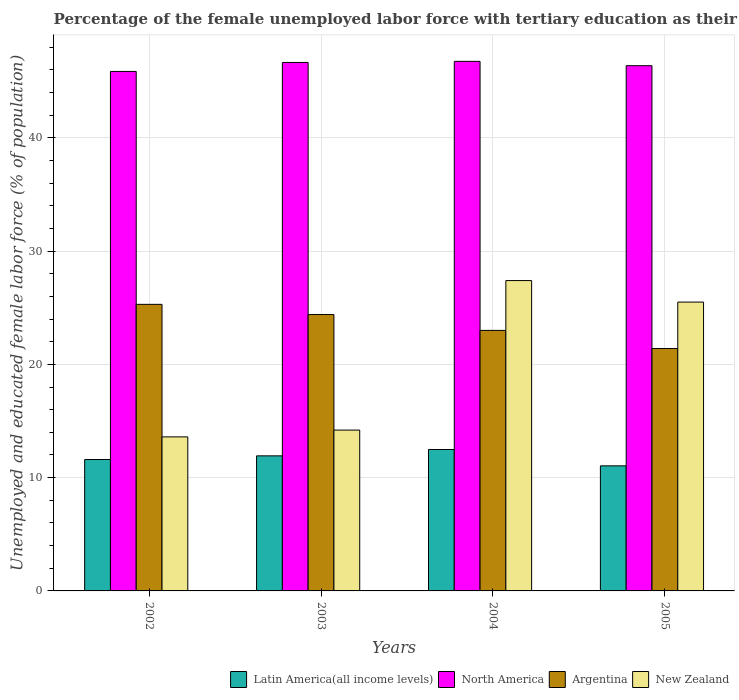How many groups of bars are there?
Ensure brevity in your answer.  4. Are the number of bars on each tick of the X-axis equal?
Your answer should be very brief. Yes. How many bars are there on the 2nd tick from the left?
Keep it short and to the point. 4. How many bars are there on the 2nd tick from the right?
Offer a terse response. 4. What is the label of the 1st group of bars from the left?
Ensure brevity in your answer.  2002. What is the percentage of the unemployed female labor force with tertiary education in Latin America(all income levels) in 2005?
Keep it short and to the point. 11.04. Across all years, what is the maximum percentage of the unemployed female labor force with tertiary education in Latin America(all income levels)?
Your response must be concise. 12.48. Across all years, what is the minimum percentage of the unemployed female labor force with tertiary education in Argentina?
Ensure brevity in your answer.  21.4. What is the total percentage of the unemployed female labor force with tertiary education in Latin America(all income levels) in the graph?
Make the answer very short. 47.05. What is the difference between the percentage of the unemployed female labor force with tertiary education in North America in 2002 and that in 2003?
Provide a short and direct response. -0.79. What is the difference between the percentage of the unemployed female labor force with tertiary education in Argentina in 2005 and the percentage of the unemployed female labor force with tertiary education in New Zealand in 2004?
Your answer should be very brief. -6. What is the average percentage of the unemployed female labor force with tertiary education in North America per year?
Your response must be concise. 46.41. In the year 2003, what is the difference between the percentage of the unemployed female labor force with tertiary education in Argentina and percentage of the unemployed female labor force with tertiary education in New Zealand?
Provide a succinct answer. 10.2. What is the ratio of the percentage of the unemployed female labor force with tertiary education in New Zealand in 2004 to that in 2005?
Ensure brevity in your answer.  1.07. Is the difference between the percentage of the unemployed female labor force with tertiary education in Argentina in 2003 and 2004 greater than the difference between the percentage of the unemployed female labor force with tertiary education in New Zealand in 2003 and 2004?
Offer a terse response. Yes. What is the difference between the highest and the second highest percentage of the unemployed female labor force with tertiary education in New Zealand?
Your answer should be very brief. 1.9. What is the difference between the highest and the lowest percentage of the unemployed female labor force with tertiary education in Argentina?
Give a very brief answer. 3.9. Is the sum of the percentage of the unemployed female labor force with tertiary education in Latin America(all income levels) in 2003 and 2005 greater than the maximum percentage of the unemployed female labor force with tertiary education in North America across all years?
Provide a short and direct response. No. What does the 3rd bar from the left in 2003 represents?
Your response must be concise. Argentina. What does the 2nd bar from the right in 2004 represents?
Your answer should be very brief. Argentina. Is it the case that in every year, the sum of the percentage of the unemployed female labor force with tertiary education in New Zealand and percentage of the unemployed female labor force with tertiary education in Latin America(all income levels) is greater than the percentage of the unemployed female labor force with tertiary education in North America?
Your response must be concise. No. Are all the bars in the graph horizontal?
Provide a short and direct response. No. What is the difference between two consecutive major ticks on the Y-axis?
Your response must be concise. 10. Are the values on the major ticks of Y-axis written in scientific E-notation?
Your response must be concise. No. Where does the legend appear in the graph?
Provide a short and direct response. Bottom right. How many legend labels are there?
Your answer should be very brief. 4. How are the legend labels stacked?
Your response must be concise. Horizontal. What is the title of the graph?
Make the answer very short. Percentage of the female unemployed labor force with tertiary education as their highest grade. What is the label or title of the X-axis?
Your answer should be compact. Years. What is the label or title of the Y-axis?
Your response must be concise. Unemployed and educated female labor force (% of population). What is the Unemployed and educated female labor force (% of population) of Latin America(all income levels) in 2002?
Give a very brief answer. 11.6. What is the Unemployed and educated female labor force (% of population) of North America in 2002?
Your answer should be very brief. 45.86. What is the Unemployed and educated female labor force (% of population) in Argentina in 2002?
Make the answer very short. 25.3. What is the Unemployed and educated female labor force (% of population) in New Zealand in 2002?
Offer a very short reply. 13.6. What is the Unemployed and educated female labor force (% of population) in Latin America(all income levels) in 2003?
Make the answer very short. 11.92. What is the Unemployed and educated female labor force (% of population) in North America in 2003?
Provide a short and direct response. 46.66. What is the Unemployed and educated female labor force (% of population) in Argentina in 2003?
Your answer should be very brief. 24.4. What is the Unemployed and educated female labor force (% of population) of New Zealand in 2003?
Offer a terse response. 14.2. What is the Unemployed and educated female labor force (% of population) in Latin America(all income levels) in 2004?
Make the answer very short. 12.48. What is the Unemployed and educated female labor force (% of population) in North America in 2004?
Provide a succinct answer. 46.75. What is the Unemployed and educated female labor force (% of population) in Argentina in 2004?
Give a very brief answer. 23. What is the Unemployed and educated female labor force (% of population) of New Zealand in 2004?
Offer a terse response. 27.4. What is the Unemployed and educated female labor force (% of population) of Latin America(all income levels) in 2005?
Make the answer very short. 11.04. What is the Unemployed and educated female labor force (% of population) of North America in 2005?
Offer a very short reply. 46.37. What is the Unemployed and educated female labor force (% of population) of Argentina in 2005?
Offer a very short reply. 21.4. Across all years, what is the maximum Unemployed and educated female labor force (% of population) in Latin America(all income levels)?
Your answer should be compact. 12.48. Across all years, what is the maximum Unemployed and educated female labor force (% of population) of North America?
Provide a short and direct response. 46.75. Across all years, what is the maximum Unemployed and educated female labor force (% of population) in Argentina?
Provide a short and direct response. 25.3. Across all years, what is the maximum Unemployed and educated female labor force (% of population) in New Zealand?
Offer a very short reply. 27.4. Across all years, what is the minimum Unemployed and educated female labor force (% of population) in Latin America(all income levels)?
Your answer should be very brief. 11.04. Across all years, what is the minimum Unemployed and educated female labor force (% of population) in North America?
Your answer should be very brief. 45.86. Across all years, what is the minimum Unemployed and educated female labor force (% of population) of Argentina?
Provide a short and direct response. 21.4. Across all years, what is the minimum Unemployed and educated female labor force (% of population) of New Zealand?
Your answer should be very brief. 13.6. What is the total Unemployed and educated female labor force (% of population) of Latin America(all income levels) in the graph?
Provide a succinct answer. 47.05. What is the total Unemployed and educated female labor force (% of population) of North America in the graph?
Offer a terse response. 185.64. What is the total Unemployed and educated female labor force (% of population) of Argentina in the graph?
Provide a succinct answer. 94.1. What is the total Unemployed and educated female labor force (% of population) of New Zealand in the graph?
Provide a short and direct response. 80.7. What is the difference between the Unemployed and educated female labor force (% of population) of Latin America(all income levels) in 2002 and that in 2003?
Provide a short and direct response. -0.32. What is the difference between the Unemployed and educated female labor force (% of population) of North America in 2002 and that in 2003?
Offer a very short reply. -0.79. What is the difference between the Unemployed and educated female labor force (% of population) in Latin America(all income levels) in 2002 and that in 2004?
Your response must be concise. -0.88. What is the difference between the Unemployed and educated female labor force (% of population) in North America in 2002 and that in 2004?
Provide a short and direct response. -0.89. What is the difference between the Unemployed and educated female labor force (% of population) of New Zealand in 2002 and that in 2004?
Provide a short and direct response. -13.8. What is the difference between the Unemployed and educated female labor force (% of population) in Latin America(all income levels) in 2002 and that in 2005?
Provide a short and direct response. 0.56. What is the difference between the Unemployed and educated female labor force (% of population) in North America in 2002 and that in 2005?
Provide a short and direct response. -0.51. What is the difference between the Unemployed and educated female labor force (% of population) of Latin America(all income levels) in 2003 and that in 2004?
Keep it short and to the point. -0.56. What is the difference between the Unemployed and educated female labor force (% of population) in North America in 2003 and that in 2004?
Your answer should be compact. -0.1. What is the difference between the Unemployed and educated female labor force (% of population) in Latin America(all income levels) in 2003 and that in 2005?
Offer a terse response. 0.88. What is the difference between the Unemployed and educated female labor force (% of population) in North America in 2003 and that in 2005?
Provide a short and direct response. 0.29. What is the difference between the Unemployed and educated female labor force (% of population) in Argentina in 2003 and that in 2005?
Keep it short and to the point. 3. What is the difference between the Unemployed and educated female labor force (% of population) in New Zealand in 2003 and that in 2005?
Keep it short and to the point. -11.3. What is the difference between the Unemployed and educated female labor force (% of population) in Latin America(all income levels) in 2004 and that in 2005?
Make the answer very short. 1.44. What is the difference between the Unemployed and educated female labor force (% of population) in North America in 2004 and that in 2005?
Provide a short and direct response. 0.38. What is the difference between the Unemployed and educated female labor force (% of population) in New Zealand in 2004 and that in 2005?
Give a very brief answer. 1.9. What is the difference between the Unemployed and educated female labor force (% of population) of Latin America(all income levels) in 2002 and the Unemployed and educated female labor force (% of population) of North America in 2003?
Your response must be concise. -35.05. What is the difference between the Unemployed and educated female labor force (% of population) in Latin America(all income levels) in 2002 and the Unemployed and educated female labor force (% of population) in Argentina in 2003?
Your answer should be very brief. -12.8. What is the difference between the Unemployed and educated female labor force (% of population) of Latin America(all income levels) in 2002 and the Unemployed and educated female labor force (% of population) of New Zealand in 2003?
Give a very brief answer. -2.6. What is the difference between the Unemployed and educated female labor force (% of population) of North America in 2002 and the Unemployed and educated female labor force (% of population) of Argentina in 2003?
Your response must be concise. 21.46. What is the difference between the Unemployed and educated female labor force (% of population) in North America in 2002 and the Unemployed and educated female labor force (% of population) in New Zealand in 2003?
Your answer should be compact. 31.66. What is the difference between the Unemployed and educated female labor force (% of population) of Latin America(all income levels) in 2002 and the Unemployed and educated female labor force (% of population) of North America in 2004?
Ensure brevity in your answer.  -35.15. What is the difference between the Unemployed and educated female labor force (% of population) of Latin America(all income levels) in 2002 and the Unemployed and educated female labor force (% of population) of Argentina in 2004?
Make the answer very short. -11.4. What is the difference between the Unemployed and educated female labor force (% of population) of Latin America(all income levels) in 2002 and the Unemployed and educated female labor force (% of population) of New Zealand in 2004?
Give a very brief answer. -15.8. What is the difference between the Unemployed and educated female labor force (% of population) of North America in 2002 and the Unemployed and educated female labor force (% of population) of Argentina in 2004?
Offer a terse response. 22.86. What is the difference between the Unemployed and educated female labor force (% of population) in North America in 2002 and the Unemployed and educated female labor force (% of population) in New Zealand in 2004?
Your answer should be compact. 18.46. What is the difference between the Unemployed and educated female labor force (% of population) of Latin America(all income levels) in 2002 and the Unemployed and educated female labor force (% of population) of North America in 2005?
Offer a very short reply. -34.77. What is the difference between the Unemployed and educated female labor force (% of population) of Latin America(all income levels) in 2002 and the Unemployed and educated female labor force (% of population) of Argentina in 2005?
Offer a terse response. -9.8. What is the difference between the Unemployed and educated female labor force (% of population) of Latin America(all income levels) in 2002 and the Unemployed and educated female labor force (% of population) of New Zealand in 2005?
Provide a short and direct response. -13.9. What is the difference between the Unemployed and educated female labor force (% of population) of North America in 2002 and the Unemployed and educated female labor force (% of population) of Argentina in 2005?
Your answer should be compact. 24.46. What is the difference between the Unemployed and educated female labor force (% of population) of North America in 2002 and the Unemployed and educated female labor force (% of population) of New Zealand in 2005?
Offer a terse response. 20.36. What is the difference between the Unemployed and educated female labor force (% of population) in Argentina in 2002 and the Unemployed and educated female labor force (% of population) in New Zealand in 2005?
Provide a succinct answer. -0.2. What is the difference between the Unemployed and educated female labor force (% of population) in Latin America(all income levels) in 2003 and the Unemployed and educated female labor force (% of population) in North America in 2004?
Offer a very short reply. -34.83. What is the difference between the Unemployed and educated female labor force (% of population) of Latin America(all income levels) in 2003 and the Unemployed and educated female labor force (% of population) of Argentina in 2004?
Offer a very short reply. -11.08. What is the difference between the Unemployed and educated female labor force (% of population) in Latin America(all income levels) in 2003 and the Unemployed and educated female labor force (% of population) in New Zealand in 2004?
Ensure brevity in your answer.  -15.48. What is the difference between the Unemployed and educated female labor force (% of population) of North America in 2003 and the Unemployed and educated female labor force (% of population) of Argentina in 2004?
Your answer should be very brief. 23.66. What is the difference between the Unemployed and educated female labor force (% of population) in North America in 2003 and the Unemployed and educated female labor force (% of population) in New Zealand in 2004?
Provide a succinct answer. 19.26. What is the difference between the Unemployed and educated female labor force (% of population) of Argentina in 2003 and the Unemployed and educated female labor force (% of population) of New Zealand in 2004?
Provide a succinct answer. -3. What is the difference between the Unemployed and educated female labor force (% of population) in Latin America(all income levels) in 2003 and the Unemployed and educated female labor force (% of population) in North America in 2005?
Your answer should be very brief. -34.44. What is the difference between the Unemployed and educated female labor force (% of population) of Latin America(all income levels) in 2003 and the Unemployed and educated female labor force (% of population) of Argentina in 2005?
Make the answer very short. -9.48. What is the difference between the Unemployed and educated female labor force (% of population) in Latin America(all income levels) in 2003 and the Unemployed and educated female labor force (% of population) in New Zealand in 2005?
Your answer should be very brief. -13.58. What is the difference between the Unemployed and educated female labor force (% of population) in North America in 2003 and the Unemployed and educated female labor force (% of population) in Argentina in 2005?
Provide a succinct answer. 25.26. What is the difference between the Unemployed and educated female labor force (% of population) in North America in 2003 and the Unemployed and educated female labor force (% of population) in New Zealand in 2005?
Make the answer very short. 21.16. What is the difference between the Unemployed and educated female labor force (% of population) in Latin America(all income levels) in 2004 and the Unemployed and educated female labor force (% of population) in North America in 2005?
Your answer should be compact. -33.88. What is the difference between the Unemployed and educated female labor force (% of population) of Latin America(all income levels) in 2004 and the Unemployed and educated female labor force (% of population) of Argentina in 2005?
Your response must be concise. -8.92. What is the difference between the Unemployed and educated female labor force (% of population) of Latin America(all income levels) in 2004 and the Unemployed and educated female labor force (% of population) of New Zealand in 2005?
Give a very brief answer. -13.02. What is the difference between the Unemployed and educated female labor force (% of population) in North America in 2004 and the Unemployed and educated female labor force (% of population) in Argentina in 2005?
Provide a short and direct response. 25.35. What is the difference between the Unemployed and educated female labor force (% of population) of North America in 2004 and the Unemployed and educated female labor force (% of population) of New Zealand in 2005?
Your answer should be very brief. 21.25. What is the average Unemployed and educated female labor force (% of population) of Latin America(all income levels) per year?
Your response must be concise. 11.76. What is the average Unemployed and educated female labor force (% of population) in North America per year?
Keep it short and to the point. 46.41. What is the average Unemployed and educated female labor force (% of population) in Argentina per year?
Provide a short and direct response. 23.52. What is the average Unemployed and educated female labor force (% of population) of New Zealand per year?
Offer a terse response. 20.18. In the year 2002, what is the difference between the Unemployed and educated female labor force (% of population) of Latin America(all income levels) and Unemployed and educated female labor force (% of population) of North America?
Offer a terse response. -34.26. In the year 2002, what is the difference between the Unemployed and educated female labor force (% of population) in Latin America(all income levels) and Unemployed and educated female labor force (% of population) in Argentina?
Offer a terse response. -13.7. In the year 2002, what is the difference between the Unemployed and educated female labor force (% of population) in Latin America(all income levels) and Unemployed and educated female labor force (% of population) in New Zealand?
Give a very brief answer. -2. In the year 2002, what is the difference between the Unemployed and educated female labor force (% of population) of North America and Unemployed and educated female labor force (% of population) of Argentina?
Your answer should be very brief. 20.56. In the year 2002, what is the difference between the Unemployed and educated female labor force (% of population) in North America and Unemployed and educated female labor force (% of population) in New Zealand?
Your response must be concise. 32.26. In the year 2002, what is the difference between the Unemployed and educated female labor force (% of population) of Argentina and Unemployed and educated female labor force (% of population) of New Zealand?
Your response must be concise. 11.7. In the year 2003, what is the difference between the Unemployed and educated female labor force (% of population) in Latin America(all income levels) and Unemployed and educated female labor force (% of population) in North America?
Offer a very short reply. -34.73. In the year 2003, what is the difference between the Unemployed and educated female labor force (% of population) in Latin America(all income levels) and Unemployed and educated female labor force (% of population) in Argentina?
Offer a very short reply. -12.48. In the year 2003, what is the difference between the Unemployed and educated female labor force (% of population) in Latin America(all income levels) and Unemployed and educated female labor force (% of population) in New Zealand?
Provide a short and direct response. -2.28. In the year 2003, what is the difference between the Unemployed and educated female labor force (% of population) of North America and Unemployed and educated female labor force (% of population) of Argentina?
Offer a very short reply. 22.26. In the year 2003, what is the difference between the Unemployed and educated female labor force (% of population) of North America and Unemployed and educated female labor force (% of population) of New Zealand?
Offer a terse response. 32.46. In the year 2003, what is the difference between the Unemployed and educated female labor force (% of population) of Argentina and Unemployed and educated female labor force (% of population) of New Zealand?
Make the answer very short. 10.2. In the year 2004, what is the difference between the Unemployed and educated female labor force (% of population) of Latin America(all income levels) and Unemployed and educated female labor force (% of population) of North America?
Give a very brief answer. -34.27. In the year 2004, what is the difference between the Unemployed and educated female labor force (% of population) in Latin America(all income levels) and Unemployed and educated female labor force (% of population) in Argentina?
Your answer should be compact. -10.52. In the year 2004, what is the difference between the Unemployed and educated female labor force (% of population) in Latin America(all income levels) and Unemployed and educated female labor force (% of population) in New Zealand?
Provide a short and direct response. -14.92. In the year 2004, what is the difference between the Unemployed and educated female labor force (% of population) of North America and Unemployed and educated female labor force (% of population) of Argentina?
Provide a succinct answer. 23.75. In the year 2004, what is the difference between the Unemployed and educated female labor force (% of population) of North America and Unemployed and educated female labor force (% of population) of New Zealand?
Keep it short and to the point. 19.35. In the year 2005, what is the difference between the Unemployed and educated female labor force (% of population) in Latin America(all income levels) and Unemployed and educated female labor force (% of population) in North America?
Make the answer very short. -35.33. In the year 2005, what is the difference between the Unemployed and educated female labor force (% of population) in Latin America(all income levels) and Unemployed and educated female labor force (% of population) in Argentina?
Offer a terse response. -10.36. In the year 2005, what is the difference between the Unemployed and educated female labor force (% of population) of Latin America(all income levels) and Unemployed and educated female labor force (% of population) of New Zealand?
Make the answer very short. -14.46. In the year 2005, what is the difference between the Unemployed and educated female labor force (% of population) of North America and Unemployed and educated female labor force (% of population) of Argentina?
Offer a terse response. 24.97. In the year 2005, what is the difference between the Unemployed and educated female labor force (% of population) in North America and Unemployed and educated female labor force (% of population) in New Zealand?
Provide a short and direct response. 20.87. In the year 2005, what is the difference between the Unemployed and educated female labor force (% of population) of Argentina and Unemployed and educated female labor force (% of population) of New Zealand?
Provide a succinct answer. -4.1. What is the ratio of the Unemployed and educated female labor force (% of population) of Latin America(all income levels) in 2002 to that in 2003?
Your answer should be very brief. 0.97. What is the ratio of the Unemployed and educated female labor force (% of population) of Argentina in 2002 to that in 2003?
Provide a succinct answer. 1.04. What is the ratio of the Unemployed and educated female labor force (% of population) of New Zealand in 2002 to that in 2003?
Offer a very short reply. 0.96. What is the ratio of the Unemployed and educated female labor force (% of population) in Latin America(all income levels) in 2002 to that in 2004?
Provide a succinct answer. 0.93. What is the ratio of the Unemployed and educated female labor force (% of population) in Argentina in 2002 to that in 2004?
Ensure brevity in your answer.  1.1. What is the ratio of the Unemployed and educated female labor force (% of population) in New Zealand in 2002 to that in 2004?
Offer a terse response. 0.5. What is the ratio of the Unemployed and educated female labor force (% of population) of Latin America(all income levels) in 2002 to that in 2005?
Give a very brief answer. 1.05. What is the ratio of the Unemployed and educated female labor force (% of population) in North America in 2002 to that in 2005?
Offer a terse response. 0.99. What is the ratio of the Unemployed and educated female labor force (% of population) of Argentina in 2002 to that in 2005?
Keep it short and to the point. 1.18. What is the ratio of the Unemployed and educated female labor force (% of population) in New Zealand in 2002 to that in 2005?
Provide a short and direct response. 0.53. What is the ratio of the Unemployed and educated female labor force (% of population) of Latin America(all income levels) in 2003 to that in 2004?
Give a very brief answer. 0.96. What is the ratio of the Unemployed and educated female labor force (% of population) of Argentina in 2003 to that in 2004?
Your answer should be very brief. 1.06. What is the ratio of the Unemployed and educated female labor force (% of population) of New Zealand in 2003 to that in 2004?
Provide a succinct answer. 0.52. What is the ratio of the Unemployed and educated female labor force (% of population) of Argentina in 2003 to that in 2005?
Your answer should be very brief. 1.14. What is the ratio of the Unemployed and educated female labor force (% of population) in New Zealand in 2003 to that in 2005?
Your answer should be compact. 0.56. What is the ratio of the Unemployed and educated female labor force (% of population) in Latin America(all income levels) in 2004 to that in 2005?
Make the answer very short. 1.13. What is the ratio of the Unemployed and educated female labor force (% of population) of North America in 2004 to that in 2005?
Ensure brevity in your answer.  1.01. What is the ratio of the Unemployed and educated female labor force (% of population) in Argentina in 2004 to that in 2005?
Keep it short and to the point. 1.07. What is the ratio of the Unemployed and educated female labor force (% of population) of New Zealand in 2004 to that in 2005?
Your response must be concise. 1.07. What is the difference between the highest and the second highest Unemployed and educated female labor force (% of population) in Latin America(all income levels)?
Your answer should be very brief. 0.56. What is the difference between the highest and the second highest Unemployed and educated female labor force (% of population) of North America?
Give a very brief answer. 0.1. What is the difference between the highest and the lowest Unemployed and educated female labor force (% of population) of Latin America(all income levels)?
Provide a short and direct response. 1.44. What is the difference between the highest and the lowest Unemployed and educated female labor force (% of population) in North America?
Ensure brevity in your answer.  0.89. What is the difference between the highest and the lowest Unemployed and educated female labor force (% of population) of Argentina?
Your response must be concise. 3.9. What is the difference between the highest and the lowest Unemployed and educated female labor force (% of population) in New Zealand?
Ensure brevity in your answer.  13.8. 